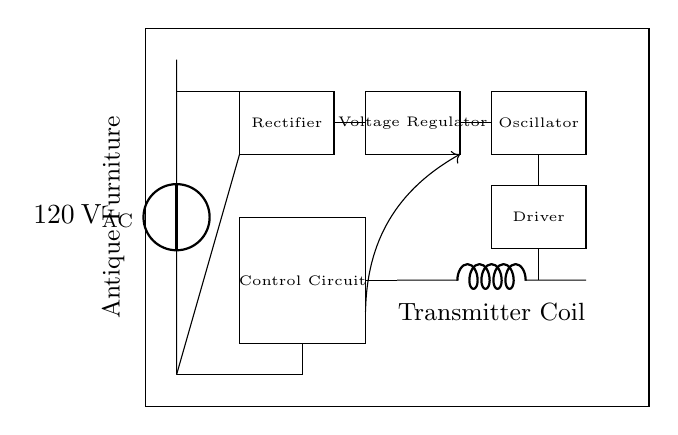What type of circuit is this? This is a wireless charging pad circuit designed for mobile devices. It includes components that convert AC power into a suitable frequency for wireless energy transfer.
Answer: wireless charging pad What is the input voltage of this circuit? The circuit receives AC power input from a voltage source rated at 120 volts. This is indicated at the input section of the circuit diagram.
Answer: 120 volts Which component regulates the voltage in this circuit? The voltage regulator is shown in the circuit diagram, indicating its role in managing the voltage levels after rectification.
Answer: Voltage Regulator What does the transmitter coil do? The transmitter coil is responsible for creating a magnetic field that transfers energy wirelessly to compatible devices. Its position in the circuit identifies its crucial function in the charging process.
Answer: Creates magnetic field What does the feedback connection in this circuit facilitate? The feedback connection from the control circuit helps to regulate the output by adjusting the oscillator settings based on the transmitted power, ensuring efficient energy transfer.
Answer: Output regulation Which component converts AC to DC in this circuit? The rectifier performs the function of converting the incoming AC voltage to DC voltage, as it is positioned right after the voltage source in the circuit diagram.
Answer: Rectifier 